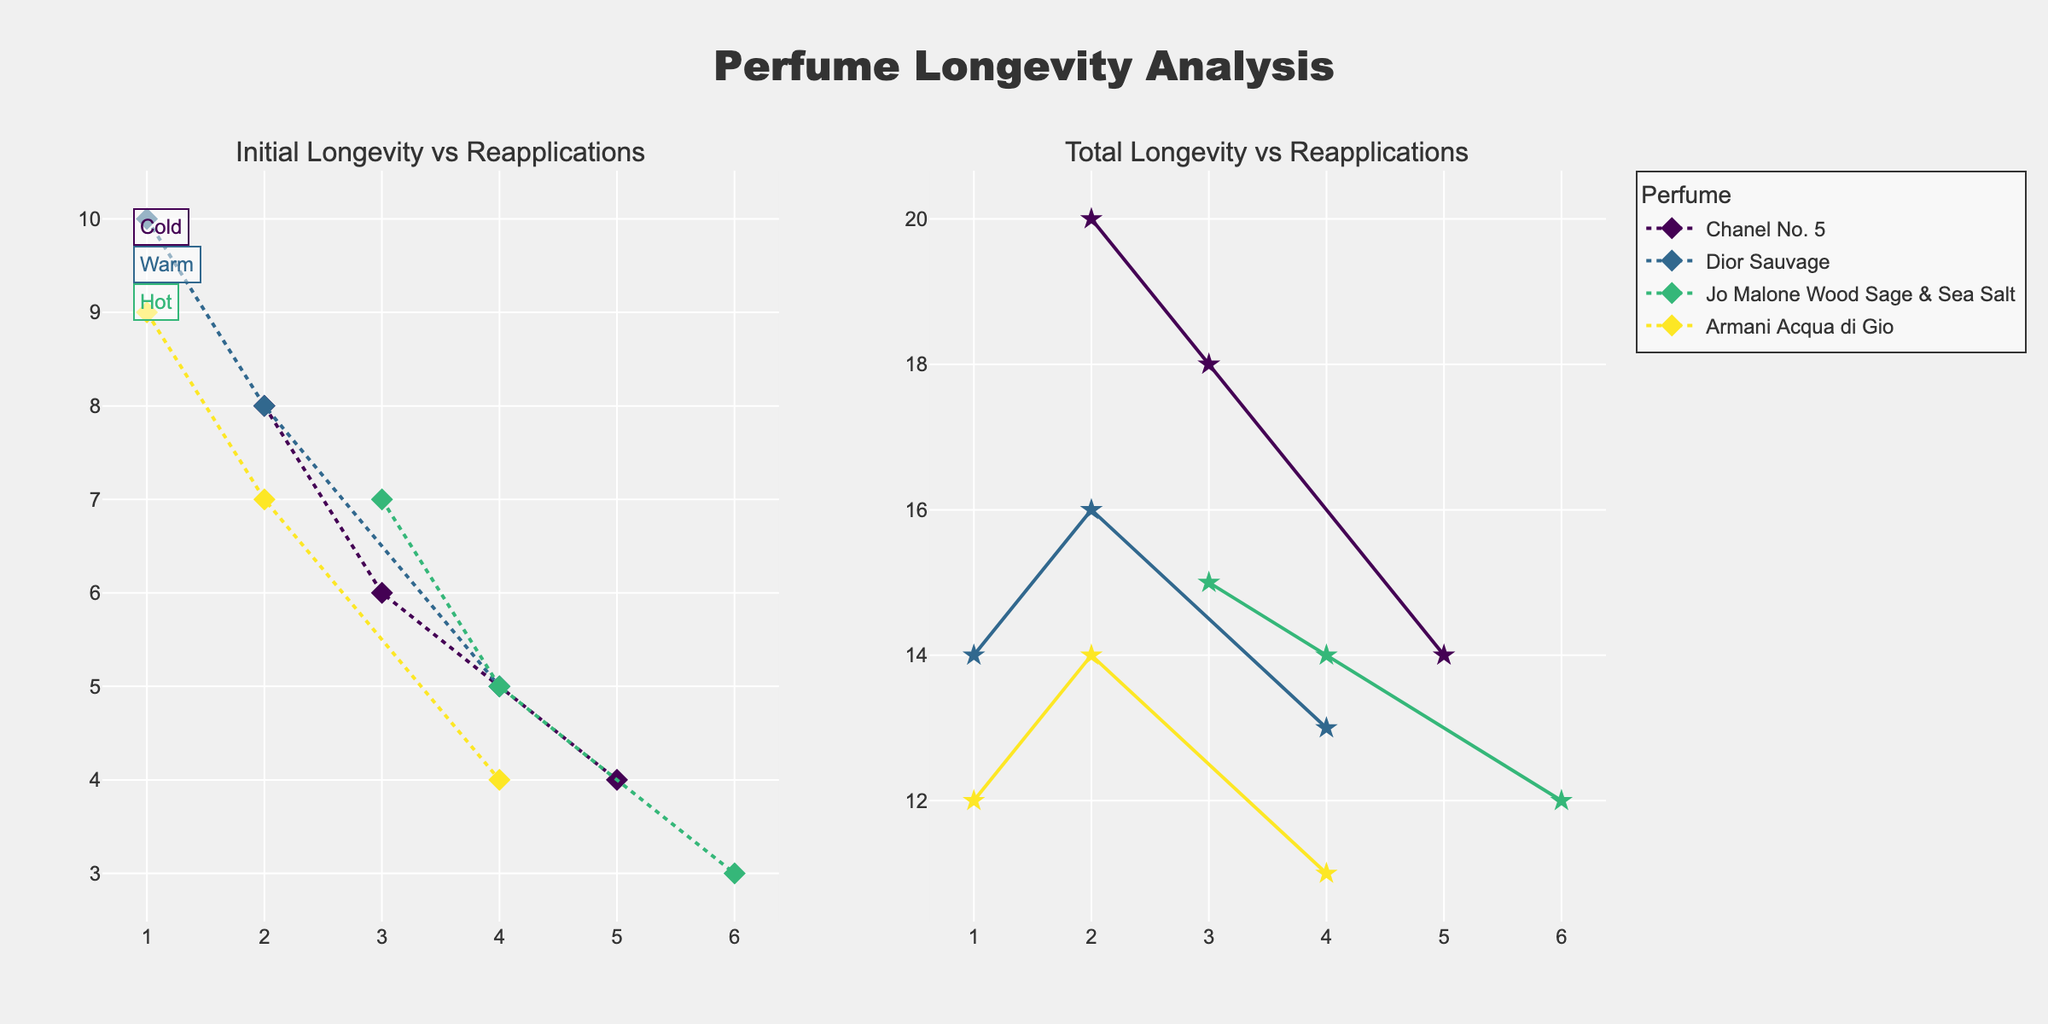What's the title of the figure? The title of a figure is usually displayed prominently at the top and is designed to give a summary or primary focus of the visualized data. In this plot, the title "Perfume Longevity Analysis" is at the top center.
Answer: Perfume Longevity Analysis How many perfumes are compared in the figure? To find the number of perfumes, look at the legend or different lines in the plot. Each unique label or line corresponds to a different perfume. Here, there are four perfumes listed in the legend.
Answer: 4 What is the maximum number of reapplications recorded in the figure? The x-axis represents the number of reapplications on a log scale. By examining the extreme right end of the x-axis, the highest value of reapplications can be identified. For this plot, the maximum number of reapplications recorded is 6.
Answer: 6 Which perfume showed the highest initial longevity in hot climates? To find this, locate data points from the "Hot" climate category and compare their initial longevities, represented by specific markers/lines. "Dior Sauvage" has the highest initial longevity of 5 hours in hot climates.
Answer: Dior Sauvage How does the longevity of Chanel No. 5 change with increasing reapplications in warm climates? Trace the changes in the total longevity along the x-axis where reapplications increase. Chanel No. 5 in warm conditions shows a decrease in initial longevity, from 6 to 5 to 4 as reapplications increase to 5.
Answer: Decreases Across all perfumes, which climate condition generally results in the highest total longevity? Compare the total longevity values across all climates (Cold, Warm, Hot). Cold climates consistently show higher values.
Answer: Cold Which perfume shows the least change in total longevity across different climate conditions? Evaluate the total longevity values for each perfume in all climates. Dior Sauvage, with values 14, 16, and 13 hours across Cold, Warm, and Hot climates, respectively, shows the least change.
Answer: Dior Sauvage What is the trend in total longevity for Jo Malone Wood Sage & Sea Salt as the number of reapplications increases in hot climates? Observe the pattern for Jo Malone in hot climates across the reapplications. Total longevity decreases from 3 to 6 reapplications, reflected in the total longevity reducing from 12 to 14 hours.
Answer: Decreases Compare the initial and total longevity for Armani Acqua di Gio in cold climates. For cold climates, check the initial and total longevity values for Armani Acqua di Gio. The initial longevity is 9 hours, while the total longevity is 12 hours with 1 reapplication.
Answer: 9 hours (initial), 12 hours (total) On a logarithmic scale, what is the range of total longevity observed in the figure? Identify the smallest and largest total longevity values, then interpret them on a log scale. The total longevity ranges from approximately 11 to 20 hours.
Answer: 11 to 20 hours 